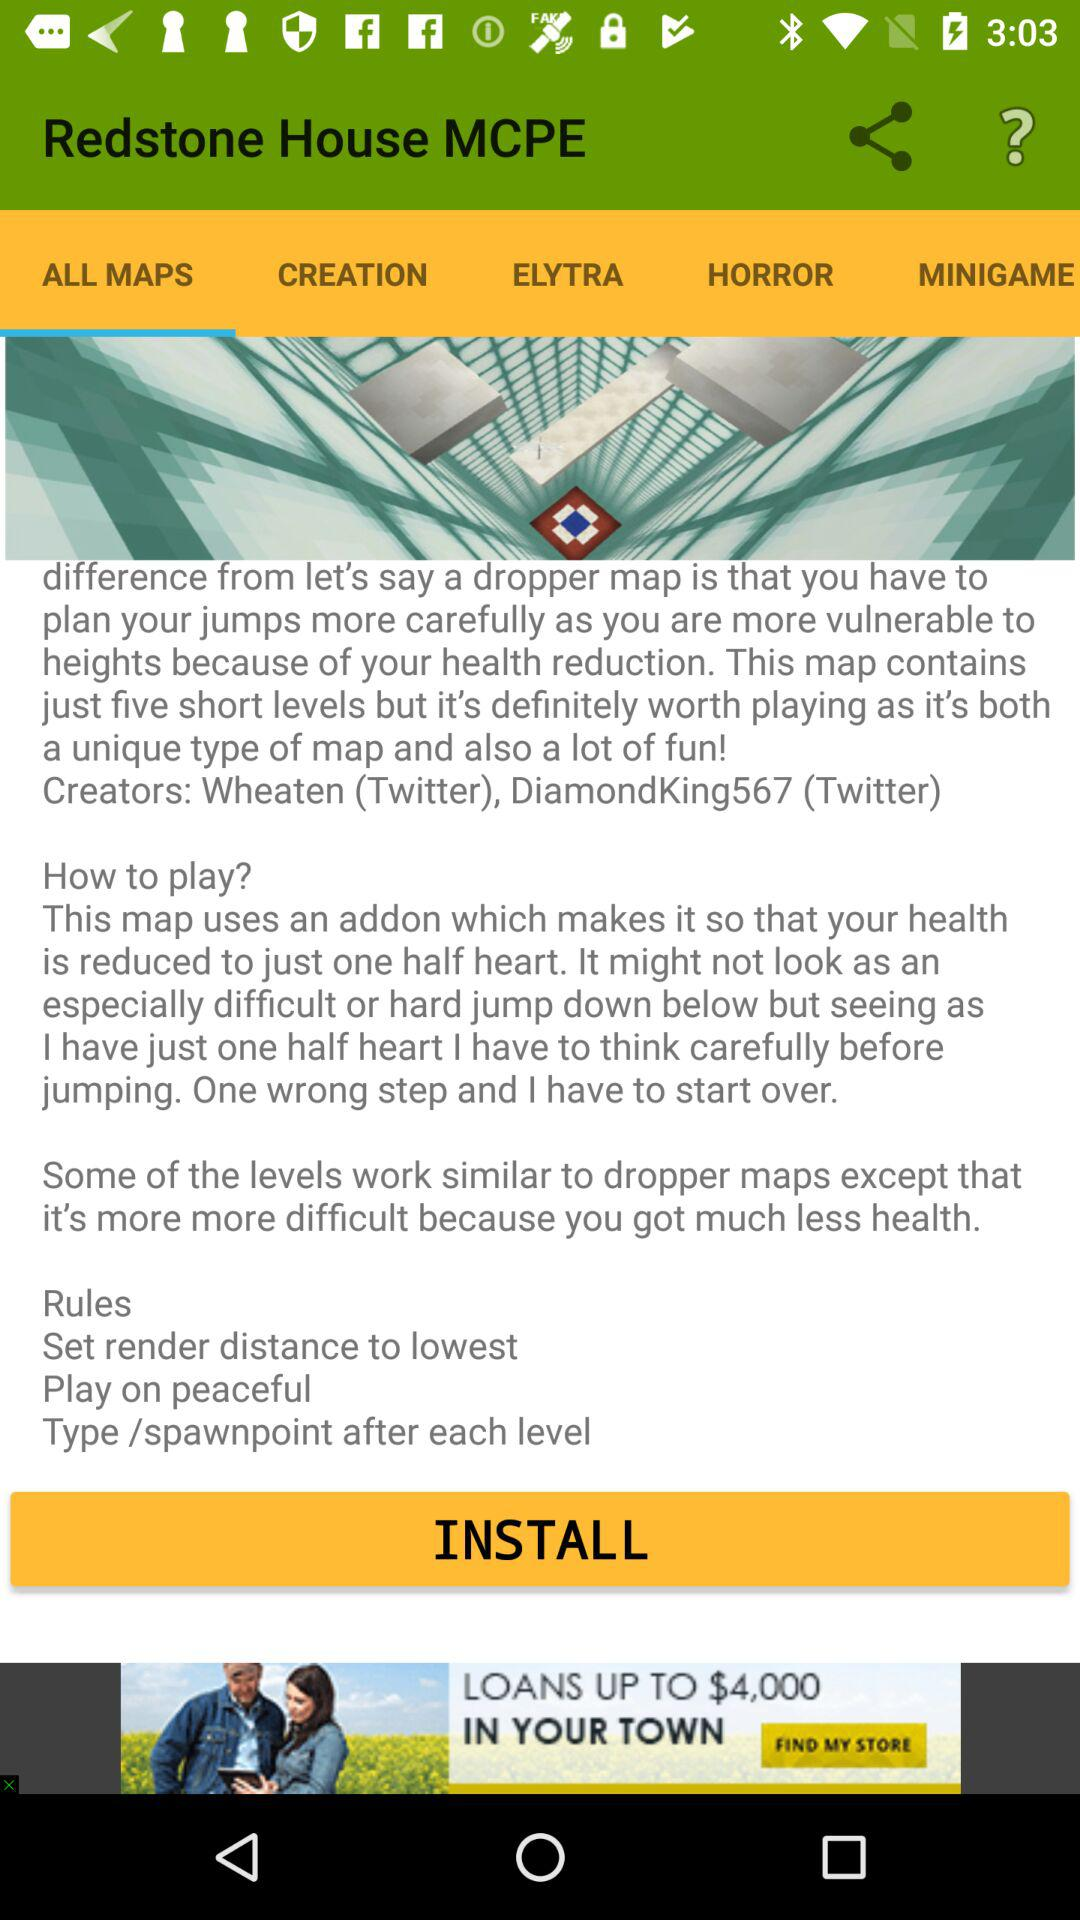Which tab is selected? The selected tab is "ALL MAPS". 